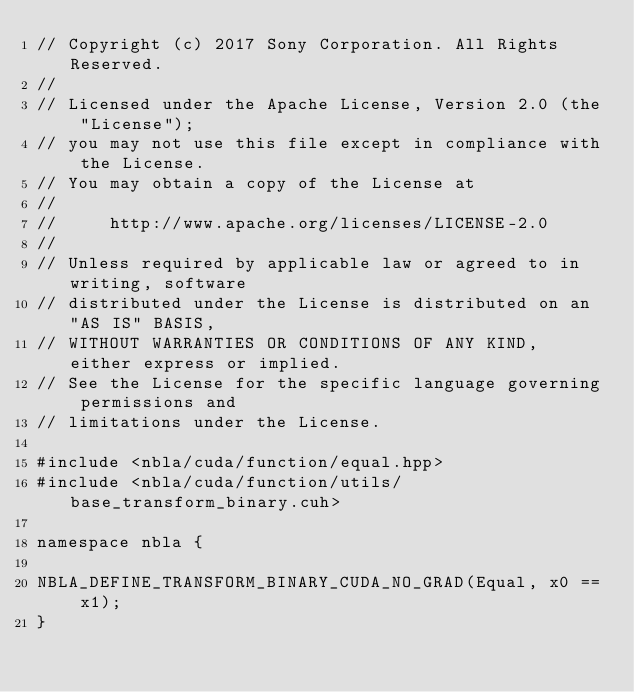Convert code to text. <code><loc_0><loc_0><loc_500><loc_500><_Cuda_>// Copyright (c) 2017 Sony Corporation. All Rights Reserved.
//
// Licensed under the Apache License, Version 2.0 (the "License");
// you may not use this file except in compliance with the License.
// You may obtain a copy of the License at
//
//     http://www.apache.org/licenses/LICENSE-2.0
//
// Unless required by applicable law or agreed to in writing, software
// distributed under the License is distributed on an "AS IS" BASIS,
// WITHOUT WARRANTIES OR CONDITIONS OF ANY KIND, either express or implied.
// See the License for the specific language governing permissions and
// limitations under the License.

#include <nbla/cuda/function/equal.hpp>
#include <nbla/cuda/function/utils/base_transform_binary.cuh>

namespace nbla {

NBLA_DEFINE_TRANSFORM_BINARY_CUDA_NO_GRAD(Equal, x0 == x1);
}
</code> 